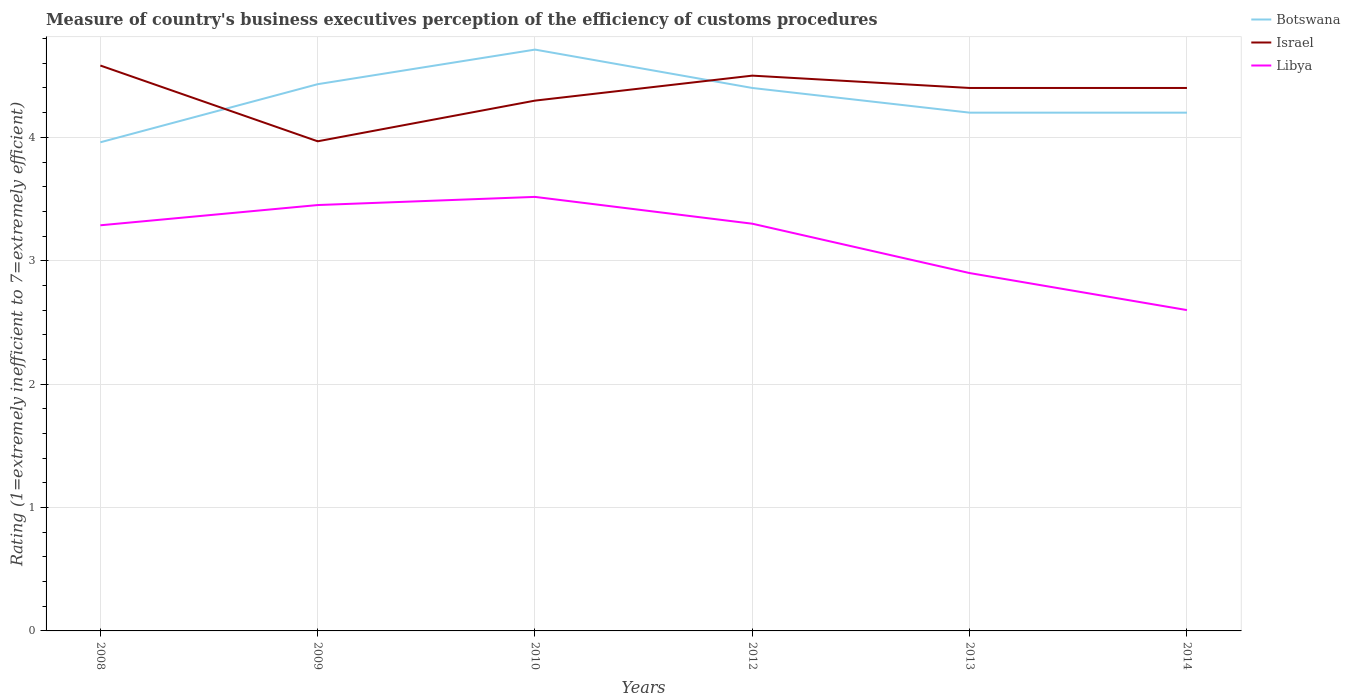Across all years, what is the maximum rating of the efficiency of customs procedure in Botswana?
Give a very brief answer. 3.96. What is the total rating of the efficiency of customs procedure in Israel in the graph?
Your answer should be very brief. 0.18. What is the difference between the highest and the second highest rating of the efficiency of customs procedure in Libya?
Provide a short and direct response. 0.92. Is the rating of the efficiency of customs procedure in Libya strictly greater than the rating of the efficiency of customs procedure in Israel over the years?
Offer a very short reply. Yes. How many lines are there?
Provide a succinct answer. 3. What is the difference between two consecutive major ticks on the Y-axis?
Ensure brevity in your answer.  1. Are the values on the major ticks of Y-axis written in scientific E-notation?
Provide a short and direct response. No. Does the graph contain any zero values?
Give a very brief answer. No. Does the graph contain grids?
Make the answer very short. Yes. How are the legend labels stacked?
Offer a terse response. Vertical. What is the title of the graph?
Offer a very short reply. Measure of country's business executives perception of the efficiency of customs procedures. What is the label or title of the X-axis?
Ensure brevity in your answer.  Years. What is the label or title of the Y-axis?
Your answer should be compact. Rating (1=extremely inefficient to 7=extremely efficient). What is the Rating (1=extremely inefficient to 7=extremely efficient) of Botswana in 2008?
Offer a terse response. 3.96. What is the Rating (1=extremely inefficient to 7=extremely efficient) in Israel in 2008?
Provide a short and direct response. 4.58. What is the Rating (1=extremely inefficient to 7=extremely efficient) in Libya in 2008?
Offer a very short reply. 3.29. What is the Rating (1=extremely inefficient to 7=extremely efficient) of Botswana in 2009?
Make the answer very short. 4.43. What is the Rating (1=extremely inefficient to 7=extremely efficient) of Israel in 2009?
Offer a very short reply. 3.97. What is the Rating (1=extremely inefficient to 7=extremely efficient) in Libya in 2009?
Offer a terse response. 3.45. What is the Rating (1=extremely inefficient to 7=extremely efficient) in Botswana in 2010?
Make the answer very short. 4.71. What is the Rating (1=extremely inefficient to 7=extremely efficient) in Israel in 2010?
Your response must be concise. 4.3. What is the Rating (1=extremely inefficient to 7=extremely efficient) of Libya in 2010?
Keep it short and to the point. 3.52. What is the Rating (1=extremely inefficient to 7=extremely efficient) of Botswana in 2012?
Keep it short and to the point. 4.4. What is the Rating (1=extremely inefficient to 7=extremely efficient) in Libya in 2013?
Offer a terse response. 2.9. What is the Rating (1=extremely inefficient to 7=extremely efficient) in Botswana in 2014?
Make the answer very short. 4.2. Across all years, what is the maximum Rating (1=extremely inefficient to 7=extremely efficient) of Botswana?
Your answer should be very brief. 4.71. Across all years, what is the maximum Rating (1=extremely inefficient to 7=extremely efficient) in Israel?
Ensure brevity in your answer.  4.58. Across all years, what is the maximum Rating (1=extremely inefficient to 7=extremely efficient) of Libya?
Make the answer very short. 3.52. Across all years, what is the minimum Rating (1=extremely inefficient to 7=extremely efficient) of Botswana?
Provide a succinct answer. 3.96. Across all years, what is the minimum Rating (1=extremely inefficient to 7=extremely efficient) of Israel?
Your answer should be very brief. 3.97. What is the total Rating (1=extremely inefficient to 7=extremely efficient) of Botswana in the graph?
Offer a very short reply. 25.9. What is the total Rating (1=extremely inefficient to 7=extremely efficient) in Israel in the graph?
Offer a terse response. 26.15. What is the total Rating (1=extremely inefficient to 7=extremely efficient) of Libya in the graph?
Provide a succinct answer. 19.06. What is the difference between the Rating (1=extremely inefficient to 7=extremely efficient) of Botswana in 2008 and that in 2009?
Provide a succinct answer. -0.47. What is the difference between the Rating (1=extremely inefficient to 7=extremely efficient) in Israel in 2008 and that in 2009?
Your response must be concise. 0.61. What is the difference between the Rating (1=extremely inefficient to 7=extremely efficient) in Libya in 2008 and that in 2009?
Your answer should be compact. -0.16. What is the difference between the Rating (1=extremely inefficient to 7=extremely efficient) in Botswana in 2008 and that in 2010?
Make the answer very short. -0.75. What is the difference between the Rating (1=extremely inefficient to 7=extremely efficient) in Israel in 2008 and that in 2010?
Make the answer very short. 0.28. What is the difference between the Rating (1=extremely inefficient to 7=extremely efficient) of Libya in 2008 and that in 2010?
Provide a succinct answer. -0.23. What is the difference between the Rating (1=extremely inefficient to 7=extremely efficient) of Botswana in 2008 and that in 2012?
Give a very brief answer. -0.44. What is the difference between the Rating (1=extremely inefficient to 7=extremely efficient) in Israel in 2008 and that in 2012?
Your answer should be very brief. 0.08. What is the difference between the Rating (1=extremely inefficient to 7=extremely efficient) in Libya in 2008 and that in 2012?
Offer a terse response. -0.01. What is the difference between the Rating (1=extremely inefficient to 7=extremely efficient) in Botswana in 2008 and that in 2013?
Your answer should be compact. -0.24. What is the difference between the Rating (1=extremely inefficient to 7=extremely efficient) of Israel in 2008 and that in 2013?
Make the answer very short. 0.18. What is the difference between the Rating (1=extremely inefficient to 7=extremely efficient) of Libya in 2008 and that in 2013?
Your answer should be compact. 0.39. What is the difference between the Rating (1=extremely inefficient to 7=extremely efficient) in Botswana in 2008 and that in 2014?
Offer a terse response. -0.24. What is the difference between the Rating (1=extremely inefficient to 7=extremely efficient) of Israel in 2008 and that in 2014?
Your answer should be compact. 0.18. What is the difference between the Rating (1=extremely inefficient to 7=extremely efficient) of Libya in 2008 and that in 2014?
Ensure brevity in your answer.  0.69. What is the difference between the Rating (1=extremely inefficient to 7=extremely efficient) of Botswana in 2009 and that in 2010?
Ensure brevity in your answer.  -0.28. What is the difference between the Rating (1=extremely inefficient to 7=extremely efficient) in Israel in 2009 and that in 2010?
Your response must be concise. -0.33. What is the difference between the Rating (1=extremely inefficient to 7=extremely efficient) in Libya in 2009 and that in 2010?
Keep it short and to the point. -0.07. What is the difference between the Rating (1=extremely inefficient to 7=extremely efficient) of Botswana in 2009 and that in 2012?
Your answer should be compact. 0.03. What is the difference between the Rating (1=extremely inefficient to 7=extremely efficient) in Israel in 2009 and that in 2012?
Make the answer very short. -0.53. What is the difference between the Rating (1=extremely inefficient to 7=extremely efficient) in Libya in 2009 and that in 2012?
Your answer should be compact. 0.15. What is the difference between the Rating (1=extremely inefficient to 7=extremely efficient) of Botswana in 2009 and that in 2013?
Offer a very short reply. 0.23. What is the difference between the Rating (1=extremely inefficient to 7=extremely efficient) of Israel in 2009 and that in 2013?
Provide a succinct answer. -0.43. What is the difference between the Rating (1=extremely inefficient to 7=extremely efficient) of Libya in 2009 and that in 2013?
Offer a terse response. 0.55. What is the difference between the Rating (1=extremely inefficient to 7=extremely efficient) in Botswana in 2009 and that in 2014?
Your answer should be compact. 0.23. What is the difference between the Rating (1=extremely inefficient to 7=extremely efficient) in Israel in 2009 and that in 2014?
Provide a short and direct response. -0.43. What is the difference between the Rating (1=extremely inefficient to 7=extremely efficient) in Libya in 2009 and that in 2014?
Keep it short and to the point. 0.85. What is the difference between the Rating (1=extremely inefficient to 7=extremely efficient) in Botswana in 2010 and that in 2012?
Offer a very short reply. 0.31. What is the difference between the Rating (1=extremely inefficient to 7=extremely efficient) in Israel in 2010 and that in 2012?
Your response must be concise. -0.2. What is the difference between the Rating (1=extremely inefficient to 7=extremely efficient) in Libya in 2010 and that in 2012?
Your response must be concise. 0.22. What is the difference between the Rating (1=extremely inefficient to 7=extremely efficient) in Botswana in 2010 and that in 2013?
Make the answer very short. 0.51. What is the difference between the Rating (1=extremely inefficient to 7=extremely efficient) in Israel in 2010 and that in 2013?
Ensure brevity in your answer.  -0.1. What is the difference between the Rating (1=extremely inefficient to 7=extremely efficient) of Libya in 2010 and that in 2013?
Offer a very short reply. 0.62. What is the difference between the Rating (1=extremely inefficient to 7=extremely efficient) in Botswana in 2010 and that in 2014?
Provide a succinct answer. 0.51. What is the difference between the Rating (1=extremely inefficient to 7=extremely efficient) of Israel in 2010 and that in 2014?
Provide a short and direct response. -0.1. What is the difference between the Rating (1=extremely inefficient to 7=extremely efficient) of Libya in 2010 and that in 2014?
Keep it short and to the point. 0.92. What is the difference between the Rating (1=extremely inefficient to 7=extremely efficient) in Israel in 2012 and that in 2013?
Your response must be concise. 0.1. What is the difference between the Rating (1=extremely inefficient to 7=extremely efficient) in Botswana in 2012 and that in 2014?
Give a very brief answer. 0.2. What is the difference between the Rating (1=extremely inefficient to 7=extremely efficient) in Israel in 2012 and that in 2014?
Your response must be concise. 0.1. What is the difference between the Rating (1=extremely inefficient to 7=extremely efficient) of Libya in 2013 and that in 2014?
Your answer should be compact. 0.3. What is the difference between the Rating (1=extremely inefficient to 7=extremely efficient) of Botswana in 2008 and the Rating (1=extremely inefficient to 7=extremely efficient) of Israel in 2009?
Give a very brief answer. -0.01. What is the difference between the Rating (1=extremely inefficient to 7=extremely efficient) in Botswana in 2008 and the Rating (1=extremely inefficient to 7=extremely efficient) in Libya in 2009?
Keep it short and to the point. 0.51. What is the difference between the Rating (1=extremely inefficient to 7=extremely efficient) of Israel in 2008 and the Rating (1=extremely inefficient to 7=extremely efficient) of Libya in 2009?
Keep it short and to the point. 1.13. What is the difference between the Rating (1=extremely inefficient to 7=extremely efficient) of Botswana in 2008 and the Rating (1=extremely inefficient to 7=extremely efficient) of Israel in 2010?
Provide a short and direct response. -0.34. What is the difference between the Rating (1=extremely inefficient to 7=extremely efficient) of Botswana in 2008 and the Rating (1=extremely inefficient to 7=extremely efficient) of Libya in 2010?
Offer a terse response. 0.44. What is the difference between the Rating (1=extremely inefficient to 7=extremely efficient) in Israel in 2008 and the Rating (1=extremely inefficient to 7=extremely efficient) in Libya in 2010?
Your response must be concise. 1.06. What is the difference between the Rating (1=extremely inefficient to 7=extremely efficient) of Botswana in 2008 and the Rating (1=extremely inefficient to 7=extremely efficient) of Israel in 2012?
Provide a short and direct response. -0.54. What is the difference between the Rating (1=extremely inefficient to 7=extremely efficient) in Botswana in 2008 and the Rating (1=extremely inefficient to 7=extremely efficient) in Libya in 2012?
Your answer should be very brief. 0.66. What is the difference between the Rating (1=extremely inefficient to 7=extremely efficient) in Israel in 2008 and the Rating (1=extremely inefficient to 7=extremely efficient) in Libya in 2012?
Offer a very short reply. 1.28. What is the difference between the Rating (1=extremely inefficient to 7=extremely efficient) in Botswana in 2008 and the Rating (1=extremely inefficient to 7=extremely efficient) in Israel in 2013?
Keep it short and to the point. -0.44. What is the difference between the Rating (1=extremely inefficient to 7=extremely efficient) in Botswana in 2008 and the Rating (1=extremely inefficient to 7=extremely efficient) in Libya in 2013?
Provide a succinct answer. 1.06. What is the difference between the Rating (1=extremely inefficient to 7=extremely efficient) in Israel in 2008 and the Rating (1=extremely inefficient to 7=extremely efficient) in Libya in 2013?
Offer a very short reply. 1.68. What is the difference between the Rating (1=extremely inefficient to 7=extremely efficient) in Botswana in 2008 and the Rating (1=extremely inefficient to 7=extremely efficient) in Israel in 2014?
Your answer should be very brief. -0.44. What is the difference between the Rating (1=extremely inefficient to 7=extremely efficient) of Botswana in 2008 and the Rating (1=extremely inefficient to 7=extremely efficient) of Libya in 2014?
Provide a short and direct response. 1.36. What is the difference between the Rating (1=extremely inefficient to 7=extremely efficient) of Israel in 2008 and the Rating (1=extremely inefficient to 7=extremely efficient) of Libya in 2014?
Your answer should be very brief. 1.98. What is the difference between the Rating (1=extremely inefficient to 7=extremely efficient) in Botswana in 2009 and the Rating (1=extremely inefficient to 7=extremely efficient) in Israel in 2010?
Ensure brevity in your answer.  0.13. What is the difference between the Rating (1=extremely inefficient to 7=extremely efficient) of Botswana in 2009 and the Rating (1=extremely inefficient to 7=extremely efficient) of Libya in 2010?
Ensure brevity in your answer.  0.91. What is the difference between the Rating (1=extremely inefficient to 7=extremely efficient) in Israel in 2009 and the Rating (1=extremely inefficient to 7=extremely efficient) in Libya in 2010?
Your response must be concise. 0.45. What is the difference between the Rating (1=extremely inefficient to 7=extremely efficient) of Botswana in 2009 and the Rating (1=extremely inefficient to 7=extremely efficient) of Israel in 2012?
Offer a terse response. -0.07. What is the difference between the Rating (1=extremely inefficient to 7=extremely efficient) in Botswana in 2009 and the Rating (1=extremely inefficient to 7=extremely efficient) in Libya in 2012?
Your answer should be compact. 1.13. What is the difference between the Rating (1=extremely inefficient to 7=extremely efficient) in Israel in 2009 and the Rating (1=extremely inefficient to 7=extremely efficient) in Libya in 2012?
Your answer should be compact. 0.67. What is the difference between the Rating (1=extremely inefficient to 7=extremely efficient) in Botswana in 2009 and the Rating (1=extremely inefficient to 7=extremely efficient) in Israel in 2013?
Provide a short and direct response. 0.03. What is the difference between the Rating (1=extremely inefficient to 7=extremely efficient) in Botswana in 2009 and the Rating (1=extremely inefficient to 7=extremely efficient) in Libya in 2013?
Ensure brevity in your answer.  1.53. What is the difference between the Rating (1=extremely inefficient to 7=extremely efficient) of Israel in 2009 and the Rating (1=extremely inefficient to 7=extremely efficient) of Libya in 2013?
Provide a short and direct response. 1.07. What is the difference between the Rating (1=extremely inefficient to 7=extremely efficient) of Botswana in 2009 and the Rating (1=extremely inefficient to 7=extremely efficient) of Israel in 2014?
Your response must be concise. 0.03. What is the difference between the Rating (1=extremely inefficient to 7=extremely efficient) in Botswana in 2009 and the Rating (1=extremely inefficient to 7=extremely efficient) in Libya in 2014?
Your answer should be compact. 1.83. What is the difference between the Rating (1=extremely inefficient to 7=extremely efficient) of Israel in 2009 and the Rating (1=extremely inefficient to 7=extremely efficient) of Libya in 2014?
Keep it short and to the point. 1.37. What is the difference between the Rating (1=extremely inefficient to 7=extremely efficient) in Botswana in 2010 and the Rating (1=extremely inefficient to 7=extremely efficient) in Israel in 2012?
Give a very brief answer. 0.21. What is the difference between the Rating (1=extremely inefficient to 7=extremely efficient) in Botswana in 2010 and the Rating (1=extremely inefficient to 7=extremely efficient) in Libya in 2012?
Your answer should be very brief. 1.41. What is the difference between the Rating (1=extremely inefficient to 7=extremely efficient) in Botswana in 2010 and the Rating (1=extremely inefficient to 7=extremely efficient) in Israel in 2013?
Keep it short and to the point. 0.31. What is the difference between the Rating (1=extremely inefficient to 7=extremely efficient) of Botswana in 2010 and the Rating (1=extremely inefficient to 7=extremely efficient) of Libya in 2013?
Keep it short and to the point. 1.81. What is the difference between the Rating (1=extremely inefficient to 7=extremely efficient) of Israel in 2010 and the Rating (1=extremely inefficient to 7=extremely efficient) of Libya in 2013?
Your answer should be compact. 1.4. What is the difference between the Rating (1=extremely inefficient to 7=extremely efficient) of Botswana in 2010 and the Rating (1=extremely inefficient to 7=extremely efficient) of Israel in 2014?
Offer a terse response. 0.31. What is the difference between the Rating (1=extremely inefficient to 7=extremely efficient) in Botswana in 2010 and the Rating (1=extremely inefficient to 7=extremely efficient) in Libya in 2014?
Provide a short and direct response. 2.11. What is the difference between the Rating (1=extremely inefficient to 7=extremely efficient) in Israel in 2010 and the Rating (1=extremely inefficient to 7=extremely efficient) in Libya in 2014?
Keep it short and to the point. 1.7. What is the difference between the Rating (1=extremely inefficient to 7=extremely efficient) of Israel in 2012 and the Rating (1=extremely inefficient to 7=extremely efficient) of Libya in 2013?
Provide a short and direct response. 1.6. What is the difference between the Rating (1=extremely inefficient to 7=extremely efficient) of Botswana in 2012 and the Rating (1=extremely inefficient to 7=extremely efficient) of Israel in 2014?
Offer a terse response. 0. What is the difference between the Rating (1=extremely inefficient to 7=extremely efficient) in Botswana in 2012 and the Rating (1=extremely inefficient to 7=extremely efficient) in Libya in 2014?
Give a very brief answer. 1.8. What is the difference between the Rating (1=extremely inefficient to 7=extremely efficient) of Israel in 2012 and the Rating (1=extremely inefficient to 7=extremely efficient) of Libya in 2014?
Ensure brevity in your answer.  1.9. What is the difference between the Rating (1=extremely inefficient to 7=extremely efficient) in Botswana in 2013 and the Rating (1=extremely inefficient to 7=extremely efficient) in Israel in 2014?
Provide a succinct answer. -0.2. What is the average Rating (1=extremely inefficient to 7=extremely efficient) in Botswana per year?
Your answer should be compact. 4.32. What is the average Rating (1=extremely inefficient to 7=extremely efficient) of Israel per year?
Your answer should be compact. 4.36. What is the average Rating (1=extremely inefficient to 7=extremely efficient) of Libya per year?
Ensure brevity in your answer.  3.18. In the year 2008, what is the difference between the Rating (1=extremely inefficient to 7=extremely efficient) of Botswana and Rating (1=extremely inefficient to 7=extremely efficient) of Israel?
Offer a very short reply. -0.62. In the year 2008, what is the difference between the Rating (1=extremely inefficient to 7=extremely efficient) of Botswana and Rating (1=extremely inefficient to 7=extremely efficient) of Libya?
Make the answer very short. 0.67. In the year 2008, what is the difference between the Rating (1=extremely inefficient to 7=extremely efficient) in Israel and Rating (1=extremely inefficient to 7=extremely efficient) in Libya?
Keep it short and to the point. 1.29. In the year 2009, what is the difference between the Rating (1=extremely inefficient to 7=extremely efficient) of Botswana and Rating (1=extremely inefficient to 7=extremely efficient) of Israel?
Your response must be concise. 0.46. In the year 2009, what is the difference between the Rating (1=extremely inefficient to 7=extremely efficient) in Botswana and Rating (1=extremely inefficient to 7=extremely efficient) in Libya?
Offer a terse response. 0.98. In the year 2009, what is the difference between the Rating (1=extremely inefficient to 7=extremely efficient) in Israel and Rating (1=extremely inefficient to 7=extremely efficient) in Libya?
Offer a terse response. 0.52. In the year 2010, what is the difference between the Rating (1=extremely inefficient to 7=extremely efficient) in Botswana and Rating (1=extremely inefficient to 7=extremely efficient) in Israel?
Ensure brevity in your answer.  0.41. In the year 2010, what is the difference between the Rating (1=extremely inefficient to 7=extremely efficient) of Botswana and Rating (1=extremely inefficient to 7=extremely efficient) of Libya?
Your answer should be compact. 1.19. In the year 2010, what is the difference between the Rating (1=extremely inefficient to 7=extremely efficient) in Israel and Rating (1=extremely inefficient to 7=extremely efficient) in Libya?
Provide a succinct answer. 0.78. In the year 2012, what is the difference between the Rating (1=extremely inefficient to 7=extremely efficient) in Botswana and Rating (1=extremely inefficient to 7=extremely efficient) in Libya?
Provide a succinct answer. 1.1. In the year 2012, what is the difference between the Rating (1=extremely inefficient to 7=extremely efficient) in Israel and Rating (1=extremely inefficient to 7=extremely efficient) in Libya?
Give a very brief answer. 1.2. In the year 2013, what is the difference between the Rating (1=extremely inefficient to 7=extremely efficient) of Botswana and Rating (1=extremely inefficient to 7=extremely efficient) of Libya?
Provide a succinct answer. 1.3. In the year 2013, what is the difference between the Rating (1=extremely inefficient to 7=extremely efficient) of Israel and Rating (1=extremely inefficient to 7=extremely efficient) of Libya?
Provide a short and direct response. 1.5. In the year 2014, what is the difference between the Rating (1=extremely inefficient to 7=extremely efficient) in Israel and Rating (1=extremely inefficient to 7=extremely efficient) in Libya?
Ensure brevity in your answer.  1.8. What is the ratio of the Rating (1=extremely inefficient to 7=extremely efficient) in Botswana in 2008 to that in 2009?
Keep it short and to the point. 0.89. What is the ratio of the Rating (1=extremely inefficient to 7=extremely efficient) of Israel in 2008 to that in 2009?
Provide a succinct answer. 1.15. What is the ratio of the Rating (1=extremely inefficient to 7=extremely efficient) in Libya in 2008 to that in 2009?
Provide a short and direct response. 0.95. What is the ratio of the Rating (1=extremely inefficient to 7=extremely efficient) of Botswana in 2008 to that in 2010?
Your answer should be compact. 0.84. What is the ratio of the Rating (1=extremely inefficient to 7=extremely efficient) of Israel in 2008 to that in 2010?
Give a very brief answer. 1.07. What is the ratio of the Rating (1=extremely inefficient to 7=extremely efficient) in Libya in 2008 to that in 2010?
Your response must be concise. 0.93. What is the ratio of the Rating (1=extremely inefficient to 7=extremely efficient) of Israel in 2008 to that in 2012?
Ensure brevity in your answer.  1.02. What is the ratio of the Rating (1=extremely inefficient to 7=extremely efficient) of Libya in 2008 to that in 2012?
Your answer should be very brief. 1. What is the ratio of the Rating (1=extremely inefficient to 7=extremely efficient) of Botswana in 2008 to that in 2013?
Ensure brevity in your answer.  0.94. What is the ratio of the Rating (1=extremely inefficient to 7=extremely efficient) in Israel in 2008 to that in 2013?
Offer a terse response. 1.04. What is the ratio of the Rating (1=extremely inefficient to 7=extremely efficient) of Libya in 2008 to that in 2013?
Offer a very short reply. 1.13. What is the ratio of the Rating (1=extremely inefficient to 7=extremely efficient) in Botswana in 2008 to that in 2014?
Give a very brief answer. 0.94. What is the ratio of the Rating (1=extremely inefficient to 7=extremely efficient) in Israel in 2008 to that in 2014?
Your response must be concise. 1.04. What is the ratio of the Rating (1=extremely inefficient to 7=extremely efficient) of Libya in 2008 to that in 2014?
Provide a succinct answer. 1.26. What is the ratio of the Rating (1=extremely inefficient to 7=extremely efficient) in Botswana in 2009 to that in 2010?
Provide a short and direct response. 0.94. What is the ratio of the Rating (1=extremely inefficient to 7=extremely efficient) in Israel in 2009 to that in 2010?
Offer a very short reply. 0.92. What is the ratio of the Rating (1=extremely inefficient to 7=extremely efficient) in Libya in 2009 to that in 2010?
Your answer should be compact. 0.98. What is the ratio of the Rating (1=extremely inefficient to 7=extremely efficient) of Israel in 2009 to that in 2012?
Provide a succinct answer. 0.88. What is the ratio of the Rating (1=extremely inefficient to 7=extremely efficient) in Libya in 2009 to that in 2012?
Your response must be concise. 1.05. What is the ratio of the Rating (1=extremely inefficient to 7=extremely efficient) in Botswana in 2009 to that in 2013?
Provide a succinct answer. 1.05. What is the ratio of the Rating (1=extremely inefficient to 7=extremely efficient) in Israel in 2009 to that in 2013?
Make the answer very short. 0.9. What is the ratio of the Rating (1=extremely inefficient to 7=extremely efficient) in Libya in 2009 to that in 2013?
Offer a very short reply. 1.19. What is the ratio of the Rating (1=extremely inefficient to 7=extremely efficient) of Botswana in 2009 to that in 2014?
Offer a very short reply. 1.05. What is the ratio of the Rating (1=extremely inefficient to 7=extremely efficient) of Israel in 2009 to that in 2014?
Make the answer very short. 0.9. What is the ratio of the Rating (1=extremely inefficient to 7=extremely efficient) of Libya in 2009 to that in 2014?
Provide a short and direct response. 1.33. What is the ratio of the Rating (1=extremely inefficient to 7=extremely efficient) in Botswana in 2010 to that in 2012?
Provide a short and direct response. 1.07. What is the ratio of the Rating (1=extremely inefficient to 7=extremely efficient) of Israel in 2010 to that in 2012?
Keep it short and to the point. 0.95. What is the ratio of the Rating (1=extremely inefficient to 7=extremely efficient) in Libya in 2010 to that in 2012?
Make the answer very short. 1.07. What is the ratio of the Rating (1=extremely inefficient to 7=extremely efficient) of Botswana in 2010 to that in 2013?
Your response must be concise. 1.12. What is the ratio of the Rating (1=extremely inefficient to 7=extremely efficient) of Israel in 2010 to that in 2013?
Your answer should be very brief. 0.98. What is the ratio of the Rating (1=extremely inefficient to 7=extremely efficient) of Libya in 2010 to that in 2013?
Your answer should be very brief. 1.21. What is the ratio of the Rating (1=extremely inefficient to 7=extremely efficient) of Botswana in 2010 to that in 2014?
Give a very brief answer. 1.12. What is the ratio of the Rating (1=extremely inefficient to 7=extremely efficient) in Israel in 2010 to that in 2014?
Provide a short and direct response. 0.98. What is the ratio of the Rating (1=extremely inefficient to 7=extremely efficient) in Libya in 2010 to that in 2014?
Your answer should be compact. 1.35. What is the ratio of the Rating (1=extremely inefficient to 7=extremely efficient) in Botswana in 2012 to that in 2013?
Offer a terse response. 1.05. What is the ratio of the Rating (1=extremely inefficient to 7=extremely efficient) in Israel in 2012 to that in 2013?
Your response must be concise. 1.02. What is the ratio of the Rating (1=extremely inefficient to 7=extremely efficient) in Libya in 2012 to that in 2013?
Ensure brevity in your answer.  1.14. What is the ratio of the Rating (1=extremely inefficient to 7=extremely efficient) of Botswana in 2012 to that in 2014?
Offer a very short reply. 1.05. What is the ratio of the Rating (1=extremely inefficient to 7=extremely efficient) of Israel in 2012 to that in 2014?
Ensure brevity in your answer.  1.02. What is the ratio of the Rating (1=extremely inefficient to 7=extremely efficient) of Libya in 2012 to that in 2014?
Give a very brief answer. 1.27. What is the ratio of the Rating (1=extremely inefficient to 7=extremely efficient) of Israel in 2013 to that in 2014?
Offer a terse response. 1. What is the ratio of the Rating (1=extremely inefficient to 7=extremely efficient) of Libya in 2013 to that in 2014?
Keep it short and to the point. 1.12. What is the difference between the highest and the second highest Rating (1=extremely inefficient to 7=extremely efficient) in Botswana?
Give a very brief answer. 0.28. What is the difference between the highest and the second highest Rating (1=extremely inefficient to 7=extremely efficient) of Israel?
Offer a terse response. 0.08. What is the difference between the highest and the second highest Rating (1=extremely inefficient to 7=extremely efficient) of Libya?
Your response must be concise. 0.07. What is the difference between the highest and the lowest Rating (1=extremely inefficient to 7=extremely efficient) of Botswana?
Ensure brevity in your answer.  0.75. What is the difference between the highest and the lowest Rating (1=extremely inefficient to 7=extremely efficient) in Israel?
Provide a short and direct response. 0.61. What is the difference between the highest and the lowest Rating (1=extremely inefficient to 7=extremely efficient) in Libya?
Provide a short and direct response. 0.92. 